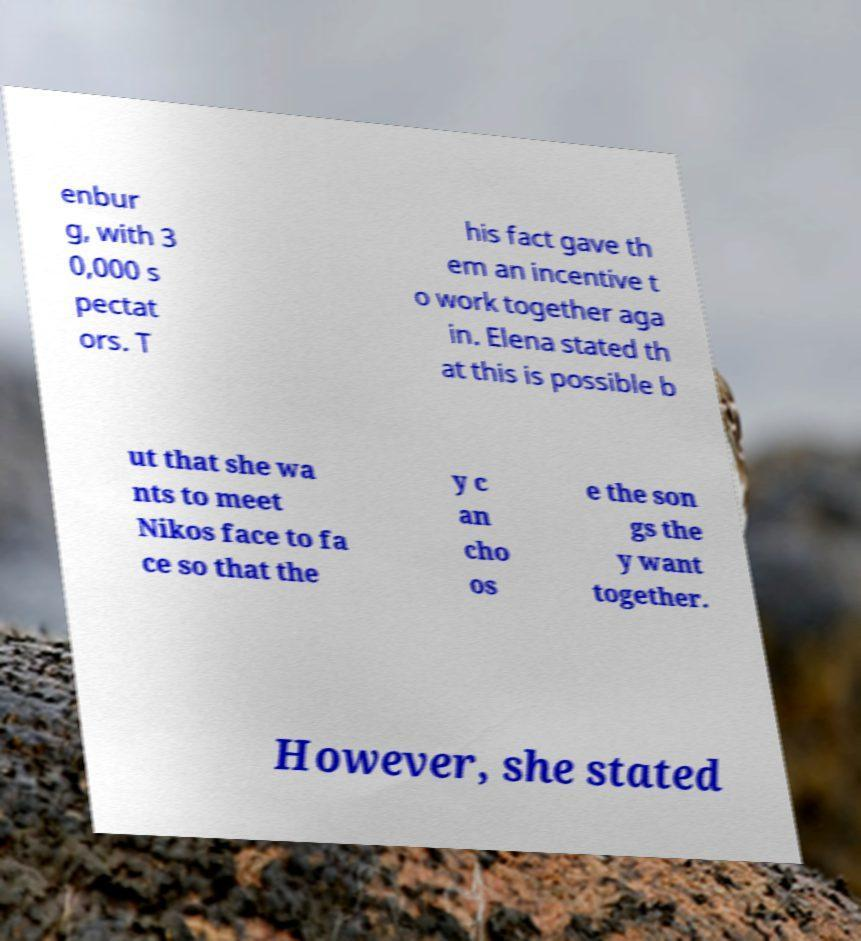Could you assist in decoding the text presented in this image and type it out clearly? enbur g, with 3 0,000 s pectat ors. T his fact gave th em an incentive t o work together aga in. Elena stated th at this is possible b ut that she wa nts to meet Nikos face to fa ce so that the y c an cho os e the son gs the y want together. However, she stated 